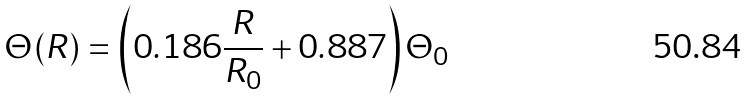Convert formula to latex. <formula><loc_0><loc_0><loc_500><loc_500>\Theta ( R ) = \left ( 0 . 1 8 6 \frac { R } { R _ { 0 } } + 0 . 8 8 7 \right ) \Theta _ { 0 }</formula> 